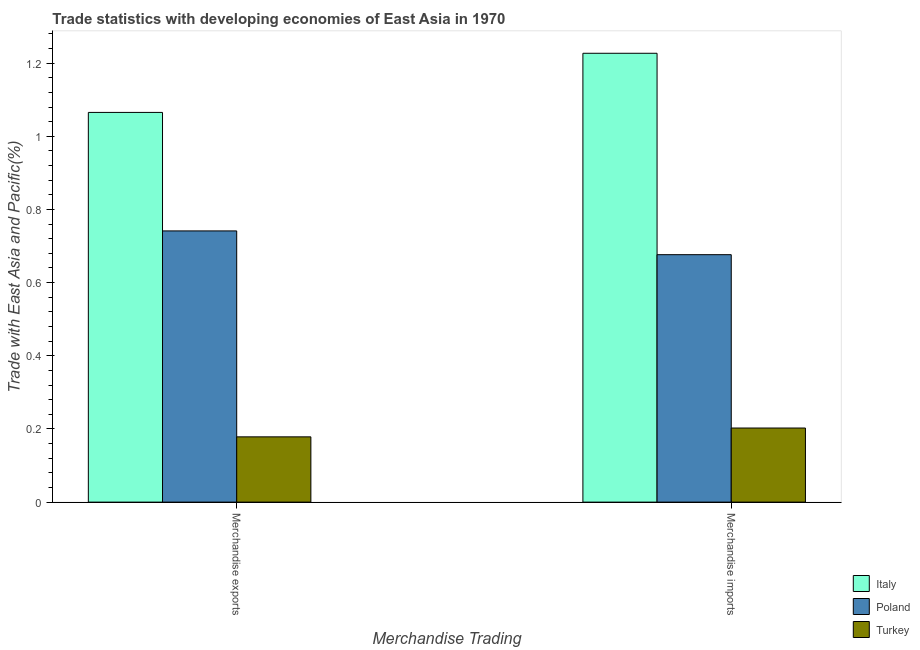How many groups of bars are there?
Offer a terse response. 2. Are the number of bars per tick equal to the number of legend labels?
Provide a succinct answer. Yes. How many bars are there on the 2nd tick from the left?
Make the answer very short. 3. How many bars are there on the 1st tick from the right?
Keep it short and to the point. 3. What is the label of the 1st group of bars from the left?
Give a very brief answer. Merchandise exports. What is the merchandise exports in Turkey?
Make the answer very short. 0.18. Across all countries, what is the maximum merchandise imports?
Ensure brevity in your answer.  1.23. Across all countries, what is the minimum merchandise exports?
Offer a terse response. 0.18. What is the total merchandise imports in the graph?
Give a very brief answer. 2.11. What is the difference between the merchandise exports in Italy and that in Turkey?
Offer a terse response. 0.89. What is the difference between the merchandise imports in Turkey and the merchandise exports in Italy?
Provide a short and direct response. -0.86. What is the average merchandise imports per country?
Give a very brief answer. 0.7. What is the difference between the merchandise exports and merchandise imports in Poland?
Make the answer very short. 0.06. What is the ratio of the merchandise imports in Poland to that in Italy?
Your answer should be compact. 0.55. In how many countries, is the merchandise exports greater than the average merchandise exports taken over all countries?
Provide a succinct answer. 2. What does the 3rd bar from the left in Merchandise imports represents?
Make the answer very short. Turkey. What does the 1st bar from the right in Merchandise exports represents?
Provide a succinct answer. Turkey. How many bars are there?
Your response must be concise. 6. Are all the bars in the graph horizontal?
Ensure brevity in your answer.  No. What is the difference between two consecutive major ticks on the Y-axis?
Your response must be concise. 0.2. Are the values on the major ticks of Y-axis written in scientific E-notation?
Offer a terse response. No. Where does the legend appear in the graph?
Offer a terse response. Bottom right. How many legend labels are there?
Provide a short and direct response. 3. What is the title of the graph?
Provide a succinct answer. Trade statistics with developing economies of East Asia in 1970. What is the label or title of the X-axis?
Keep it short and to the point. Merchandise Trading. What is the label or title of the Y-axis?
Ensure brevity in your answer.  Trade with East Asia and Pacific(%). What is the Trade with East Asia and Pacific(%) in Italy in Merchandise exports?
Offer a very short reply. 1.07. What is the Trade with East Asia and Pacific(%) of Poland in Merchandise exports?
Your response must be concise. 0.74. What is the Trade with East Asia and Pacific(%) in Turkey in Merchandise exports?
Your answer should be very brief. 0.18. What is the Trade with East Asia and Pacific(%) in Italy in Merchandise imports?
Keep it short and to the point. 1.23. What is the Trade with East Asia and Pacific(%) in Poland in Merchandise imports?
Your answer should be very brief. 0.68. What is the Trade with East Asia and Pacific(%) in Turkey in Merchandise imports?
Offer a terse response. 0.2. Across all Merchandise Trading, what is the maximum Trade with East Asia and Pacific(%) in Italy?
Make the answer very short. 1.23. Across all Merchandise Trading, what is the maximum Trade with East Asia and Pacific(%) in Poland?
Offer a very short reply. 0.74. Across all Merchandise Trading, what is the maximum Trade with East Asia and Pacific(%) of Turkey?
Make the answer very short. 0.2. Across all Merchandise Trading, what is the minimum Trade with East Asia and Pacific(%) of Italy?
Provide a short and direct response. 1.07. Across all Merchandise Trading, what is the minimum Trade with East Asia and Pacific(%) of Poland?
Your answer should be very brief. 0.68. Across all Merchandise Trading, what is the minimum Trade with East Asia and Pacific(%) in Turkey?
Provide a short and direct response. 0.18. What is the total Trade with East Asia and Pacific(%) in Italy in the graph?
Give a very brief answer. 2.29. What is the total Trade with East Asia and Pacific(%) of Poland in the graph?
Your answer should be very brief. 1.42. What is the total Trade with East Asia and Pacific(%) in Turkey in the graph?
Keep it short and to the point. 0.38. What is the difference between the Trade with East Asia and Pacific(%) in Italy in Merchandise exports and that in Merchandise imports?
Your answer should be very brief. -0.16. What is the difference between the Trade with East Asia and Pacific(%) in Poland in Merchandise exports and that in Merchandise imports?
Your answer should be very brief. 0.07. What is the difference between the Trade with East Asia and Pacific(%) in Turkey in Merchandise exports and that in Merchandise imports?
Ensure brevity in your answer.  -0.02. What is the difference between the Trade with East Asia and Pacific(%) of Italy in Merchandise exports and the Trade with East Asia and Pacific(%) of Poland in Merchandise imports?
Provide a succinct answer. 0.39. What is the difference between the Trade with East Asia and Pacific(%) of Italy in Merchandise exports and the Trade with East Asia and Pacific(%) of Turkey in Merchandise imports?
Keep it short and to the point. 0.86. What is the difference between the Trade with East Asia and Pacific(%) in Poland in Merchandise exports and the Trade with East Asia and Pacific(%) in Turkey in Merchandise imports?
Make the answer very short. 0.54. What is the average Trade with East Asia and Pacific(%) of Italy per Merchandise Trading?
Your response must be concise. 1.15. What is the average Trade with East Asia and Pacific(%) of Poland per Merchandise Trading?
Make the answer very short. 0.71. What is the average Trade with East Asia and Pacific(%) in Turkey per Merchandise Trading?
Make the answer very short. 0.19. What is the difference between the Trade with East Asia and Pacific(%) in Italy and Trade with East Asia and Pacific(%) in Poland in Merchandise exports?
Your answer should be very brief. 0.32. What is the difference between the Trade with East Asia and Pacific(%) of Italy and Trade with East Asia and Pacific(%) of Turkey in Merchandise exports?
Ensure brevity in your answer.  0.89. What is the difference between the Trade with East Asia and Pacific(%) of Poland and Trade with East Asia and Pacific(%) of Turkey in Merchandise exports?
Make the answer very short. 0.56. What is the difference between the Trade with East Asia and Pacific(%) in Italy and Trade with East Asia and Pacific(%) in Poland in Merchandise imports?
Keep it short and to the point. 0.55. What is the difference between the Trade with East Asia and Pacific(%) in Italy and Trade with East Asia and Pacific(%) in Turkey in Merchandise imports?
Make the answer very short. 1.02. What is the difference between the Trade with East Asia and Pacific(%) of Poland and Trade with East Asia and Pacific(%) of Turkey in Merchandise imports?
Your response must be concise. 0.47. What is the ratio of the Trade with East Asia and Pacific(%) in Italy in Merchandise exports to that in Merchandise imports?
Provide a succinct answer. 0.87. What is the ratio of the Trade with East Asia and Pacific(%) of Poland in Merchandise exports to that in Merchandise imports?
Offer a terse response. 1.1. What is the ratio of the Trade with East Asia and Pacific(%) of Turkey in Merchandise exports to that in Merchandise imports?
Your answer should be compact. 0.88. What is the difference between the highest and the second highest Trade with East Asia and Pacific(%) of Italy?
Ensure brevity in your answer.  0.16. What is the difference between the highest and the second highest Trade with East Asia and Pacific(%) of Poland?
Provide a short and direct response. 0.07. What is the difference between the highest and the second highest Trade with East Asia and Pacific(%) in Turkey?
Make the answer very short. 0.02. What is the difference between the highest and the lowest Trade with East Asia and Pacific(%) of Italy?
Your answer should be compact. 0.16. What is the difference between the highest and the lowest Trade with East Asia and Pacific(%) in Poland?
Keep it short and to the point. 0.07. What is the difference between the highest and the lowest Trade with East Asia and Pacific(%) of Turkey?
Your answer should be very brief. 0.02. 